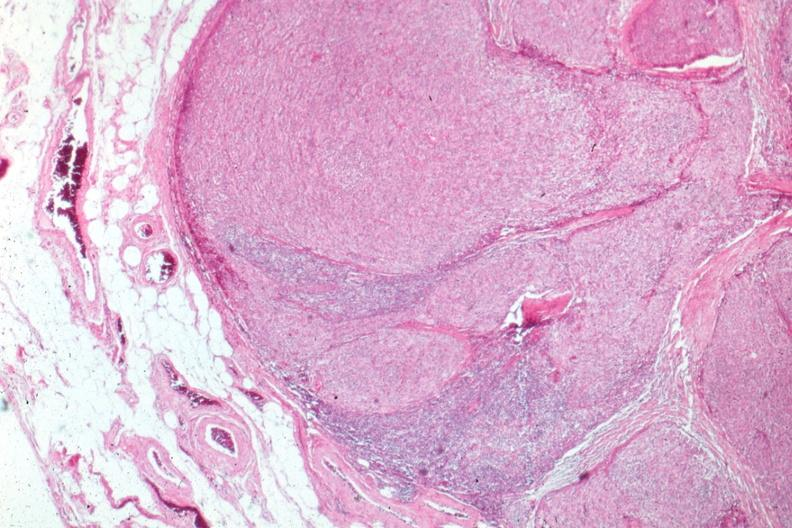what is present?
Answer the question using a single word or phrase. Thymoma 